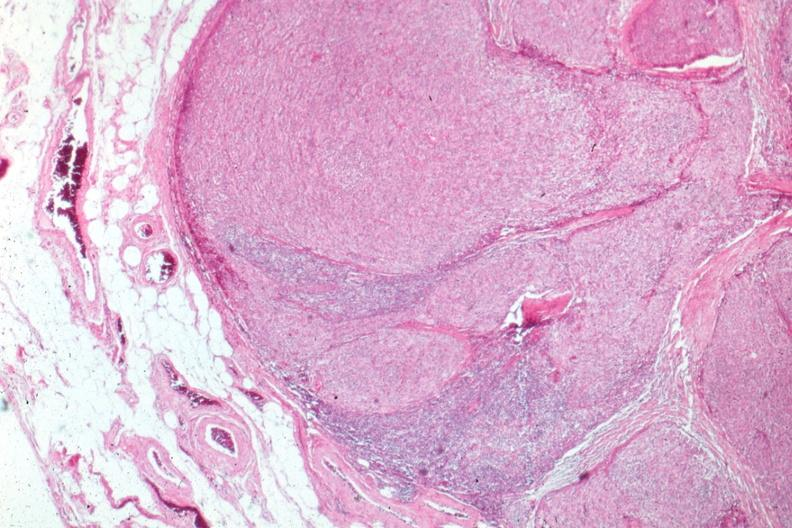what is present?
Answer the question using a single word or phrase. Thymoma 